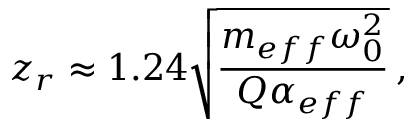Convert formula to latex. <formula><loc_0><loc_0><loc_500><loc_500>z _ { r } \approx 1 . 2 4 \sqrt { \frac { m _ { e f f } \omega _ { 0 } ^ { 2 } } { Q \alpha _ { e f f } } } \, ,</formula> 